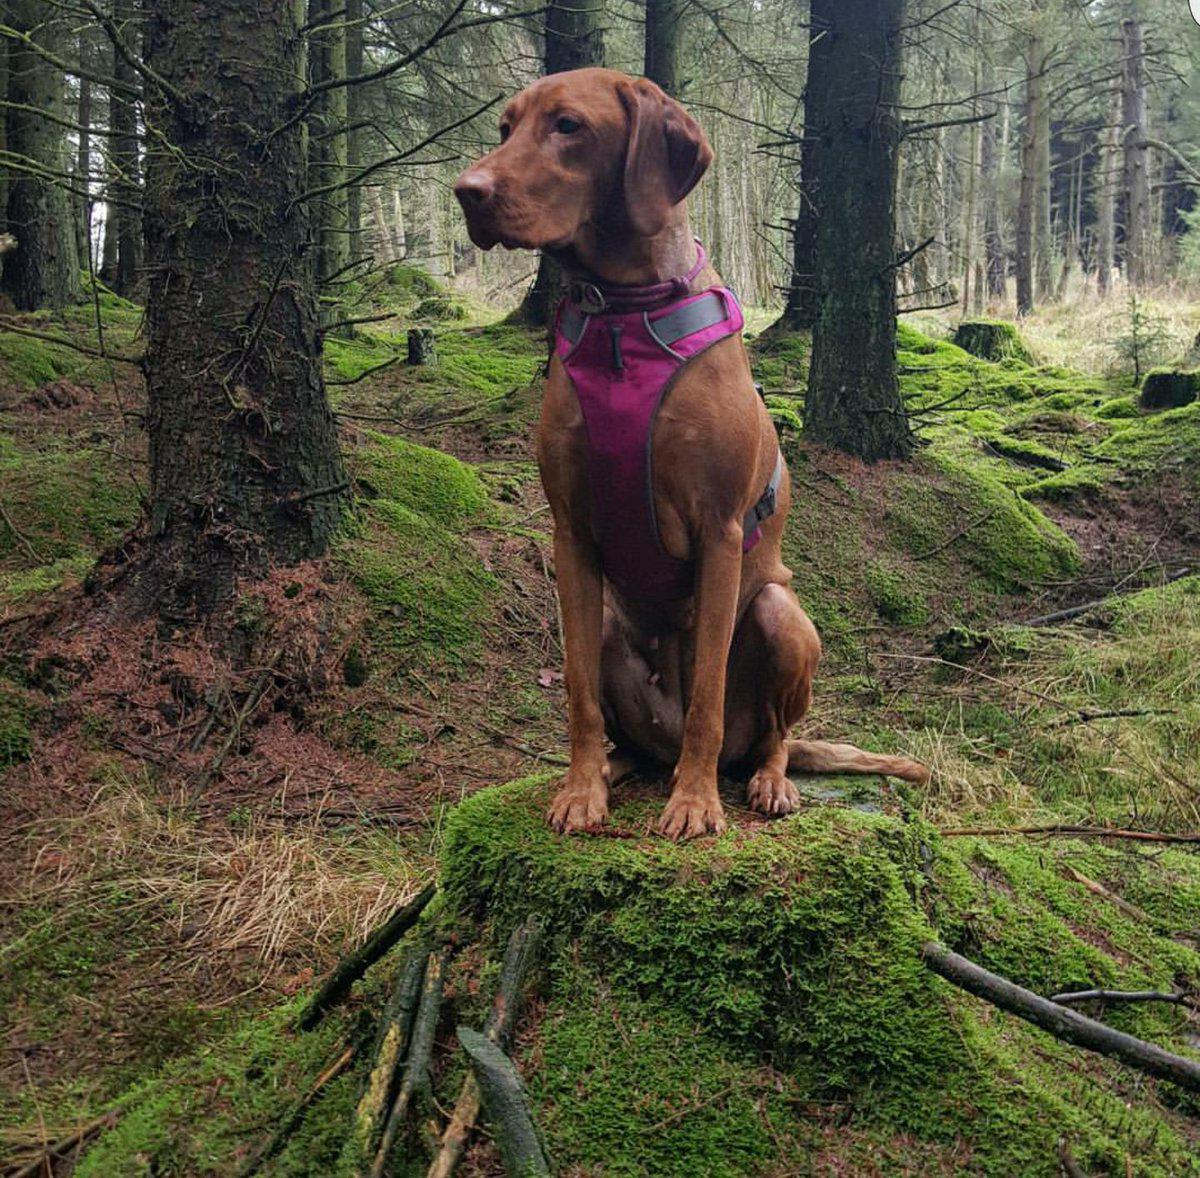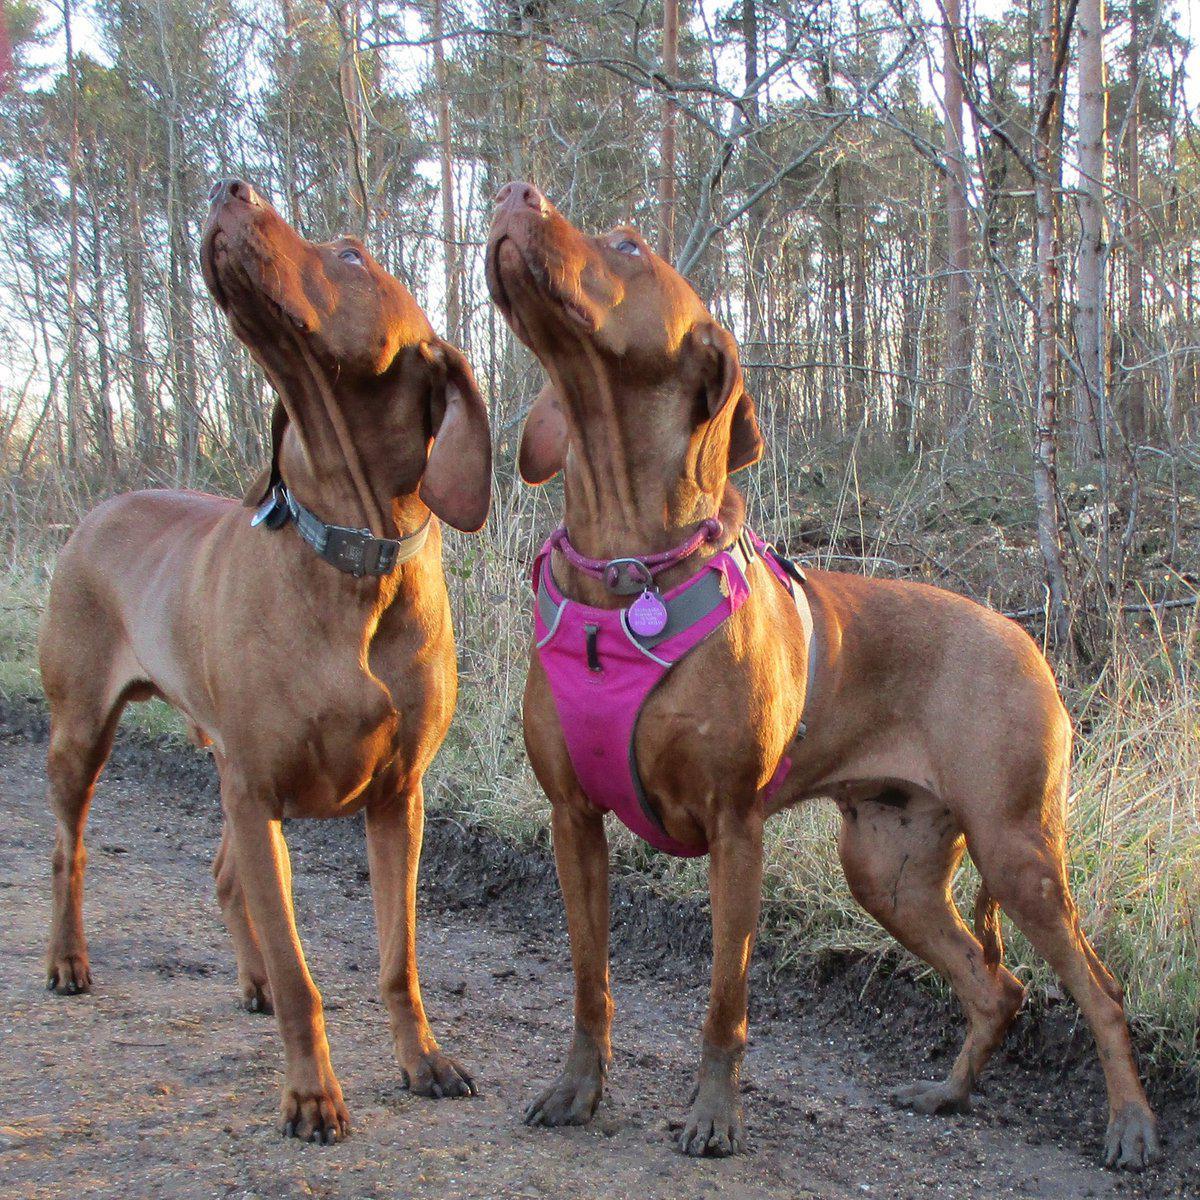The first image is the image on the left, the second image is the image on the right. For the images displayed, is the sentence "The left image shows a dog with its front paws propped up, gazing toward a scenic view away from the camera, and the right image features purple flowers behind one dog." factually correct? Answer yes or no. No. The first image is the image on the left, the second image is the image on the right. Assess this claim about the two images: "In one image, a tan dog is standing upright with its front feet on a raised area before it, the back of its head visible as it looks away.". Correct or not? Answer yes or no. No. 